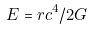Convert formula to latex. <formula><loc_0><loc_0><loc_500><loc_500>E = r c ^ { 4 } / 2 G</formula> 